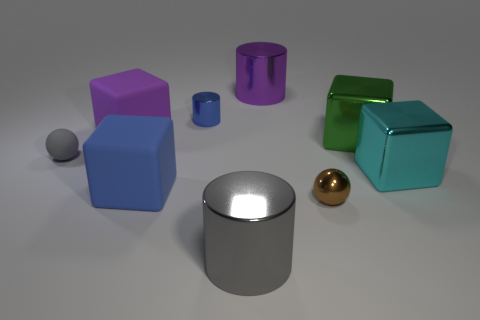What number of balls are cyan objects or large gray metal objects?
Make the answer very short. 0. What number of metallic objects are either large blue cubes or large brown balls?
Offer a very short reply. 0. There is a gray object that is the same shape as the big purple shiny thing; what is its size?
Provide a succinct answer. Large. Are there any other things that are the same size as the blue matte cube?
Provide a succinct answer. Yes. There is a purple cube; is its size the same as the gray object that is on the right side of the blue cube?
Your answer should be compact. Yes. There is a thing in front of the shiny sphere; what shape is it?
Your answer should be very brief. Cylinder. There is a tiny thing right of the small metal thing to the left of the brown thing; what is its color?
Your answer should be compact. Brown. There is another shiny object that is the same shape as the large cyan object; what is its color?
Your answer should be very brief. Green. How many things have the same color as the tiny matte sphere?
Your response must be concise. 1. There is a tiny shiny cylinder; is its color the same as the metallic object to the right of the green metal block?
Provide a short and direct response. No. 